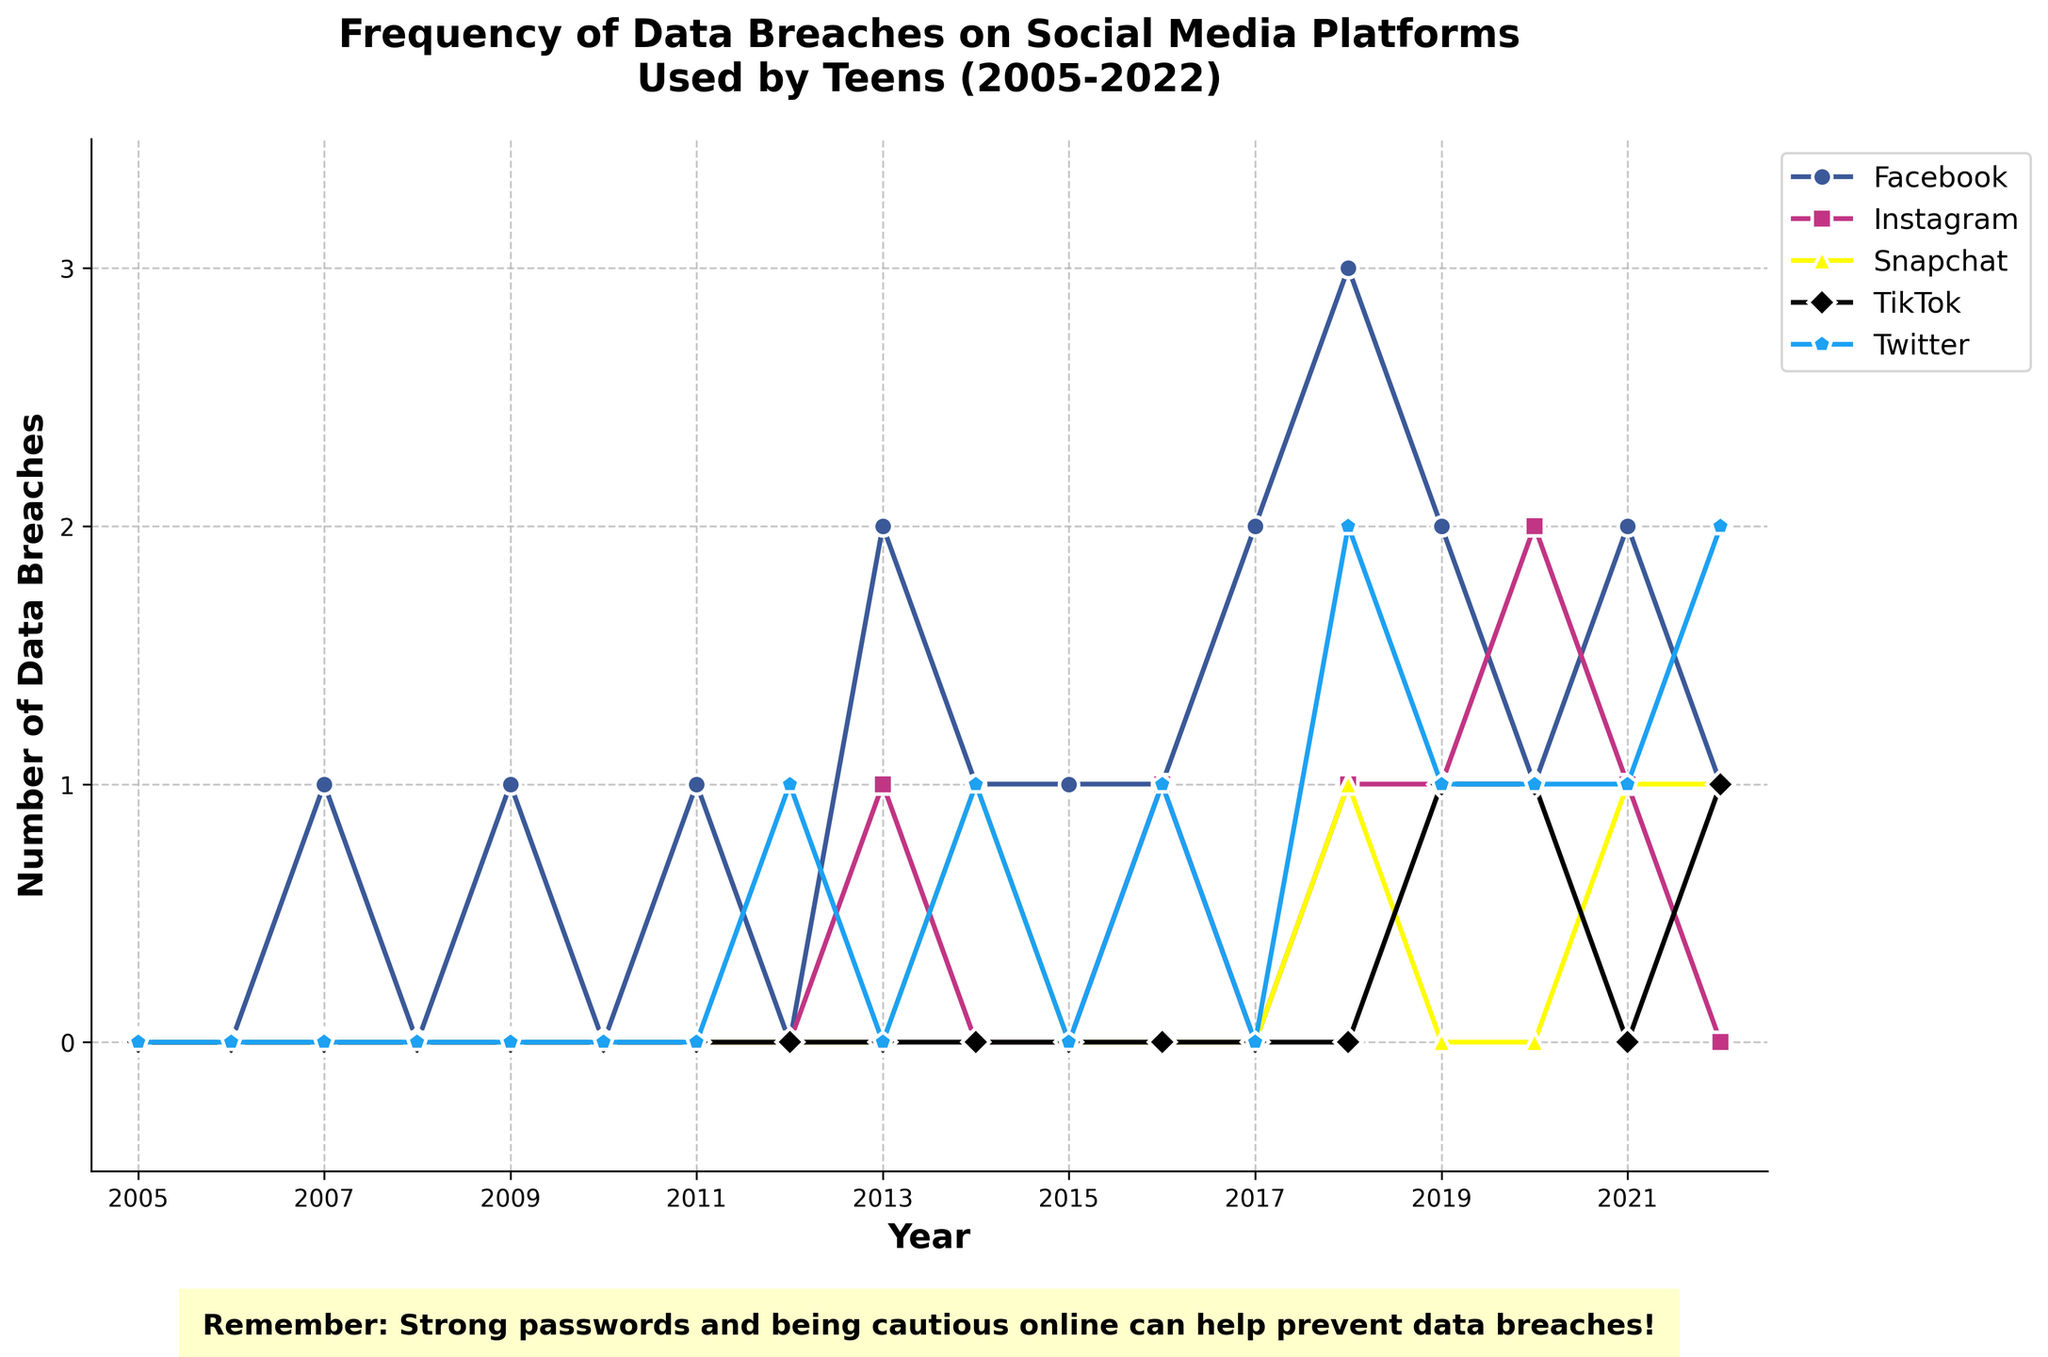Which platform had the highest number of data breaches in 2018? Looking at the line plot for 2018, the highest value across all platforms is 3, which corresponds to Facebook.
Answer: Facebook How many total data breaches did Twitter have from 2005 to 2022? To find the total number of data breaches for Twitter from 2005 to 2022, sum up the breaches for each year: 0 + 0 + 0 + 0 + 0 + 0 + 0 + 0 + 1 + 1 + 0 + 1 + 1 + 2 + 1 + 1 + 1 + 2 = 13
Answer: 13 Which year had the highest cumulative number of data breaches across all platforms? Adding up the number of breaches for all platforms for each year, 2018 has the highest total with 3 (Facebook) + 1 (Instagram) + 1 (Snapchat) + 0 (TikTok) + 2 (Twitter) = 7.
Answer: 2018 Is the number of data breaches for TikTok generally increasing or decreasing over time? TikTok shows breaches starting from 2019, with the counts being 1, 1, 0, 1. There is no clear increasing or decreasing trend.
Answer: No clear trend How many platforms had more than one data breach in 2020? In 2020, check the counts for each platform: Facebook (1), Instagram (2), Snapchat (0), TikTok (1), Twitter (1). Only Instagram has more than one breach.
Answer: 1 By what percentage did the number of data breaches for Instagram increase from 2019 to 2020? Instagram had 1 breach in 2019 and 2 breaches in 2020. The percentage increase is calculated as ((2 - 1) / 1) * 100 = 100%.
Answer: 100% Which two years had the same number of data breaches for Snapchat? Looking at the plot, Snapchat had 1 breach in 2014 and again in 2018 and 2021.
Answer: 2014 and 2018, 2018 and 2021, 2014 and 2021 What is the average number of data breaches for Facebook between 2015 and 2020? To find the average for Facebook from 2015 to 2020, sum the number of breaches (1 + 1 + 2 + 3 + 2 + 1 = 10) and divide by the number of years (6). The average is 10 / 6 ≈ 1.67.
Answer: 1.67 